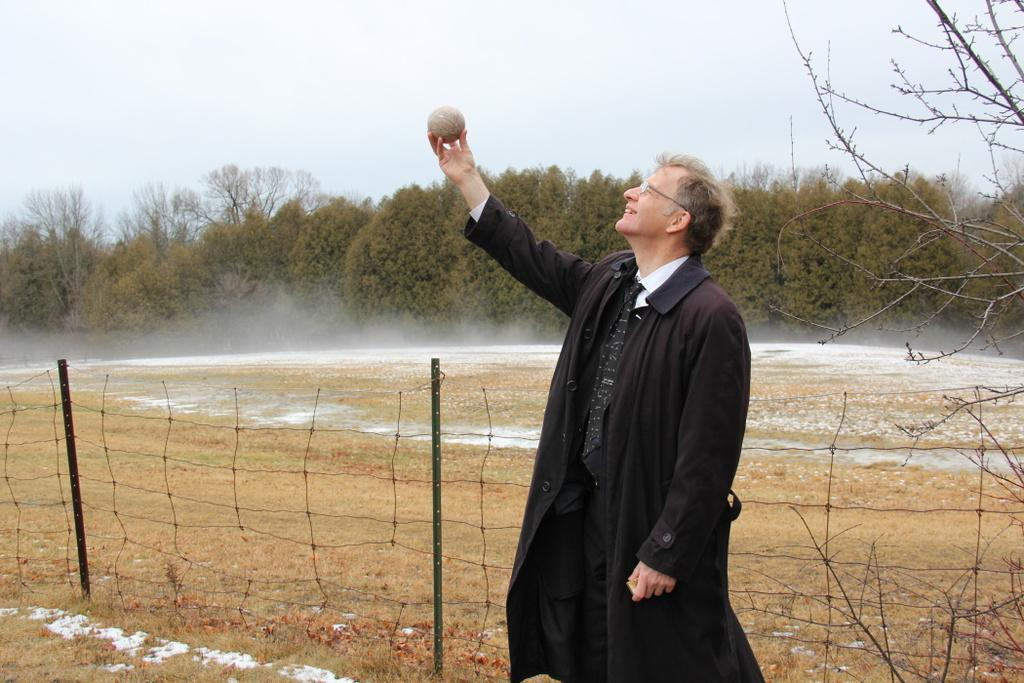What is the main subject of the image? There is a man standing in the image. What is the man wearing? The man is wearing a black coat. What can be seen behind the man? There are green trees behind the man. What is visible at the top of the image? The sky is visible at the top of the image. What type of lettuce can be seen growing in the alley behind the man? There is no alley or lettuce present in the image; it features a man standing in front of green trees. 